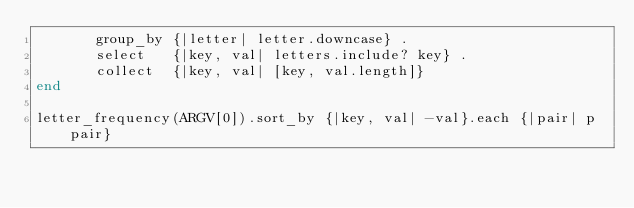Convert code to text. <code><loc_0><loc_0><loc_500><loc_500><_Ruby_>       group_by {|letter| letter.downcase} .
       select   {|key, val| letters.include? key} .
       collect  {|key, val| [key, val.length]}
end

letter_frequency(ARGV[0]).sort_by {|key, val| -val}.each {|pair| p pair}
</code> 